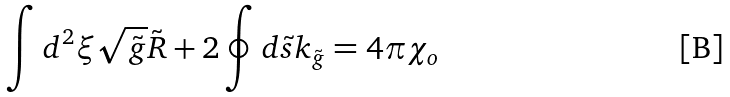<formula> <loc_0><loc_0><loc_500><loc_500>\int { d ^ { 2 } } \xi \sqrt { \tilde { g } } \tilde { R } + 2 \oint { d } \tilde { s } { k _ { \tilde { g } } } = 4 \pi { \chi _ { o } }</formula> 